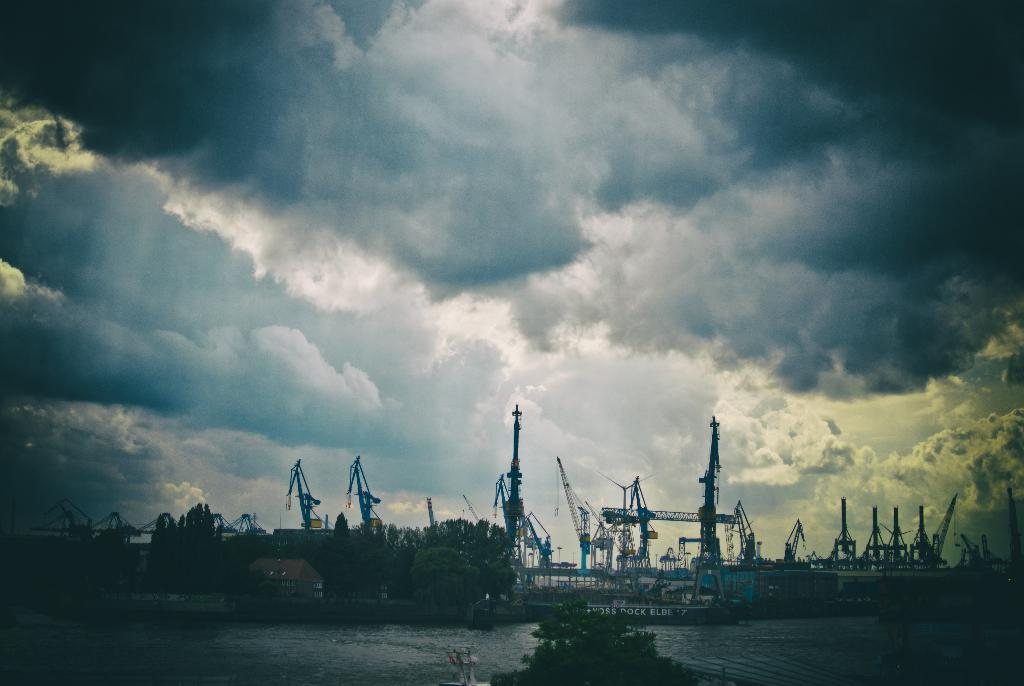What type of structure is present in the image? There is a dock in the image. What can be found on the dock? The dock contains cranes. What type of vegetation is visible in the image? There are trees in the image. What is visible in the sky in the image? There are clouds in the sky. How much wealth is displayed on the dock in the image? There is no indication of wealth in the image; it features a dock with cranes, trees, and clouds. What type of bait is being used by the cranes in the image? There are no cranes using bait in the image; the cranes are stationary on the dock. 